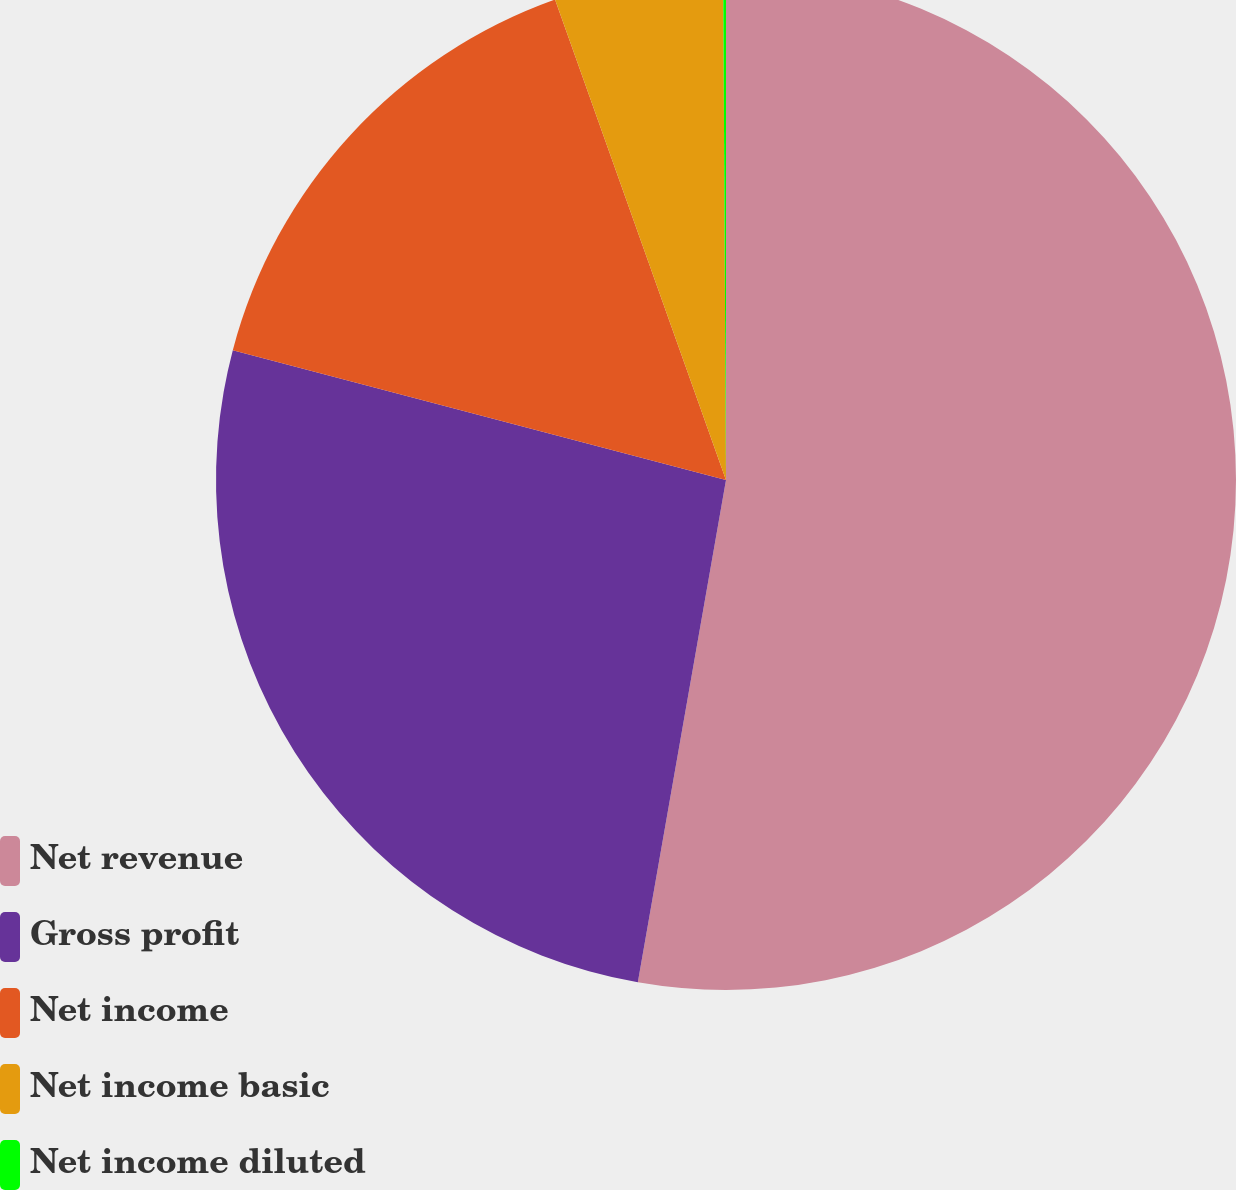Convert chart. <chart><loc_0><loc_0><loc_500><loc_500><pie_chart><fcel>Net revenue<fcel>Gross profit<fcel>Net income<fcel>Net income basic<fcel>Net income diluted<nl><fcel>52.76%<fcel>26.33%<fcel>15.46%<fcel>5.35%<fcel>0.09%<nl></chart> 